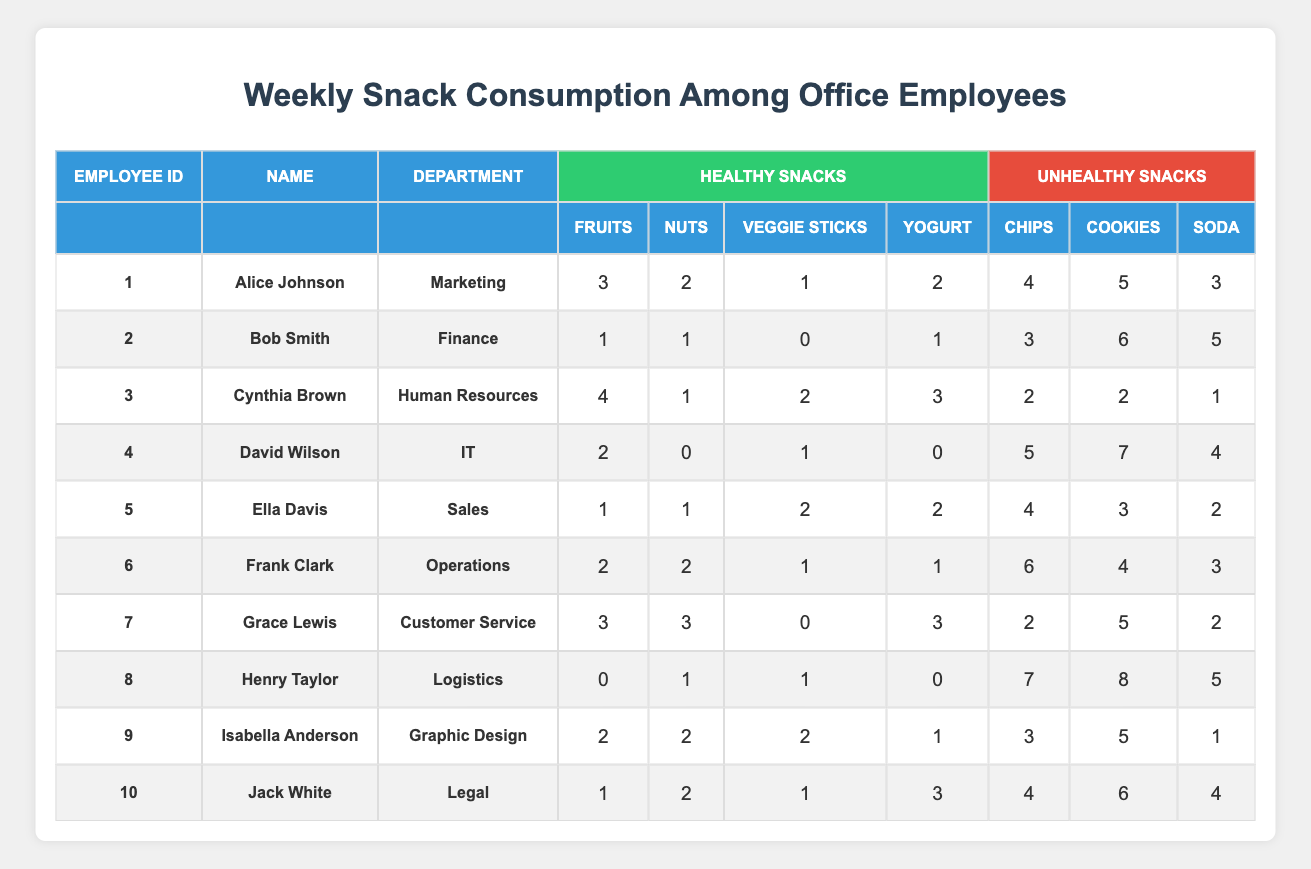What is the total number of unhealthy snacks consumed by Alice Johnson? To find the total unhealthy snacks consumed by Alice, we add up the snacks: Chips (4) + Cookies (5) + Soda (3) = 12.
Answer: 12 How many fruits did Bob Smith consume during the week? The table shows that Bob Smith consumed 1 fruit.
Answer: 1 Which employee consumed the highest number of soda? By reviewing the soda counts for each employee, Henry Taylor has the most with 5 sodas.
Answer: Henry Taylor What is the average number of healthy snacks consumed by employees in the Marketing department? Alice Johnson consumed a total of 8 healthy snacks: 3 Fruits + 2 Nuts + 1 Veggie Sticks + 2 Yogurts = 8. There is 1 employee in Marketing, so the total is 8/1 = 8.
Answer: 8 Did any employee consume more unhealthy snacks than healthy snacks? Compare each employee's total unhealthy snacks to healthy snacks: David Wilson (16 unhealthy > 3 healthy), meaning yes, he did.
Answer: Yes Who had the least number of healthy snacks overall? To find the employee with the least healthy snacks, we check each employee's total: Henry Taylor with 2 (0 Fruits + 1 Nuts + 1 Veggie Sticks + 0 Yogurts).
Answer: Henry Taylor What is the difference between the highest and lowest number of unhealthy snacks consumed? The highest number is from David Wilson (16 snacks) and the lowest is Isabella Anderson (9 snacks). The difference is 16 - 9 = 7.
Answer: 7 How many employees consumed more nuts than fruits? Reviewing the data, Alice Johnson consumed 2 Nuts and 3 Fruits, Bob Smith 1 Nut and 1 Fruit, Cynthia Brown 1 Nut and 4 Fruits, etc. Only Grace Lewis (3 Nuts and 3 Fruits) consumed equal amounts, so no one.
Answer: No What percentage of total snacks consumed by Frank Clark were unhealthy? Frank consumed 2 Fruits + 2 Nuts + 1 Veggie Stick + 1 Yogurt = 6 healthy snacks, and 6 Chips + 4 Cookies + 3 Soda = 13 unhealthy snacks. Total = 6 + 13 = 19. Percentage = (13/19) * 100 ≈ 68.42%.
Answer: 68.42% Which department had the highest total of healthy snacks consumed? Total healthy snacks for each department: Marketing (8), Finance (3), HR (10), IT (3), Sales (6), Operations (6), Customer Service (9), Logistics (2), Graphic Design (7), Legal (7). HR had the most with 10.
Answer: Human Resources 